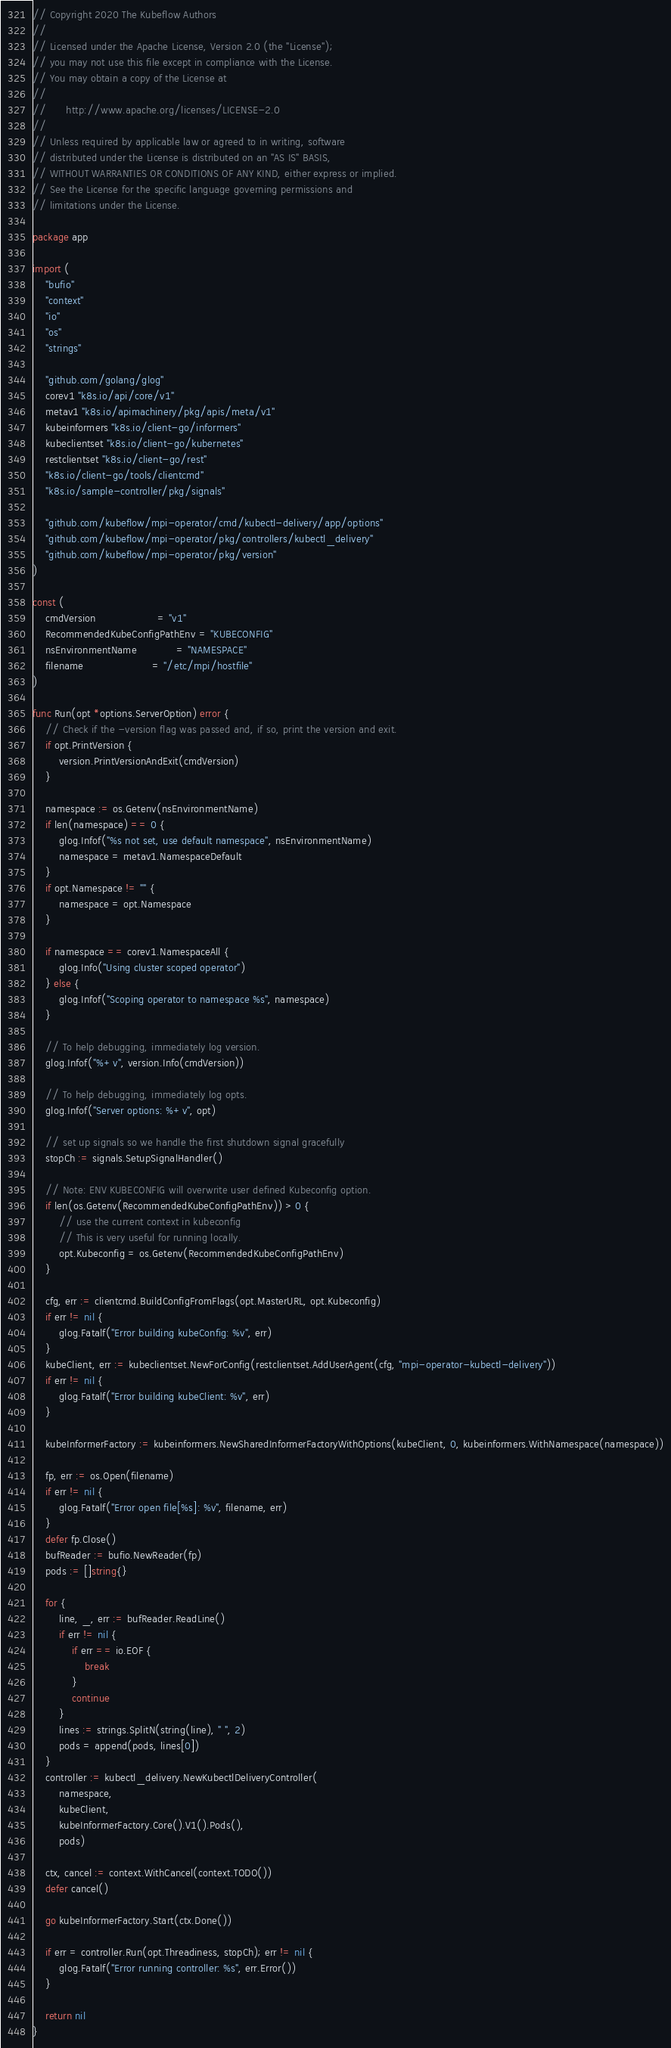<code> <loc_0><loc_0><loc_500><loc_500><_Go_>// Copyright 2020 The Kubeflow Authors
//
// Licensed under the Apache License, Version 2.0 (the "License");
// you may not use this file except in compliance with the License.
// You may obtain a copy of the License at
//
//      http://www.apache.org/licenses/LICENSE-2.0
//
// Unless required by applicable law or agreed to in writing, software
// distributed under the License is distributed on an "AS IS" BASIS,
// WITHOUT WARRANTIES OR CONDITIONS OF ANY KIND, either express or implied.
// See the License for the specific language governing permissions and
// limitations under the License.

package app

import (
	"bufio"
	"context"
	"io"
	"os"
	"strings"

	"github.com/golang/glog"
	corev1 "k8s.io/api/core/v1"
	metav1 "k8s.io/apimachinery/pkg/apis/meta/v1"
	kubeinformers "k8s.io/client-go/informers"
	kubeclientset "k8s.io/client-go/kubernetes"
	restclientset "k8s.io/client-go/rest"
	"k8s.io/client-go/tools/clientcmd"
	"k8s.io/sample-controller/pkg/signals"

	"github.com/kubeflow/mpi-operator/cmd/kubectl-delivery/app/options"
	"github.com/kubeflow/mpi-operator/pkg/controllers/kubectl_delivery"
	"github.com/kubeflow/mpi-operator/pkg/version"
)

const (
	cmdVersion                   = "v1"
	RecommendedKubeConfigPathEnv = "KUBECONFIG"
	nsEnvironmentName            = "NAMESPACE"
	filename                     = "/etc/mpi/hostfile"
)

func Run(opt *options.ServerOption) error {
	// Check if the -version flag was passed and, if so, print the version and exit.
	if opt.PrintVersion {
		version.PrintVersionAndExit(cmdVersion)
	}

	namespace := os.Getenv(nsEnvironmentName)
	if len(namespace) == 0 {
		glog.Infof("%s not set, use default namespace", nsEnvironmentName)
		namespace = metav1.NamespaceDefault
	}
	if opt.Namespace != "" {
		namespace = opt.Namespace
	}

	if namespace == corev1.NamespaceAll {
		glog.Info("Using cluster scoped operator")
	} else {
		glog.Infof("Scoping operator to namespace %s", namespace)
	}

	// To help debugging, immediately log version.
	glog.Infof("%+v", version.Info(cmdVersion))

	// To help debugging, immediately log opts.
	glog.Infof("Server options: %+v", opt)

	// set up signals so we handle the first shutdown signal gracefully
	stopCh := signals.SetupSignalHandler()

	// Note: ENV KUBECONFIG will overwrite user defined Kubeconfig option.
	if len(os.Getenv(RecommendedKubeConfigPathEnv)) > 0 {
		// use the current context in kubeconfig
		// This is very useful for running locally.
		opt.Kubeconfig = os.Getenv(RecommendedKubeConfigPathEnv)
	}

	cfg, err := clientcmd.BuildConfigFromFlags(opt.MasterURL, opt.Kubeconfig)
	if err != nil {
		glog.Fatalf("Error building kubeConfig: %v", err)
	}
	kubeClient, err := kubeclientset.NewForConfig(restclientset.AddUserAgent(cfg, "mpi-operator-kubectl-delivery"))
	if err != nil {
		glog.Fatalf("Error building kubeClient: %v", err)
	}

	kubeInformerFactory := kubeinformers.NewSharedInformerFactoryWithOptions(kubeClient, 0, kubeinformers.WithNamespace(namespace))

	fp, err := os.Open(filename)
	if err != nil {
		glog.Fatalf("Error open file[%s]: %v", filename, err)
	}
	defer fp.Close()
	bufReader := bufio.NewReader(fp)
	pods := []string{}

	for {
		line, _, err := bufReader.ReadLine()
		if err != nil {
			if err == io.EOF {
				break
			}
			continue
		}
		lines := strings.SplitN(string(line), " ", 2)
		pods = append(pods, lines[0])
	}
	controller := kubectl_delivery.NewKubectlDeliveryController(
		namespace,
		kubeClient,
		kubeInformerFactory.Core().V1().Pods(),
		pods)

	ctx, cancel := context.WithCancel(context.TODO())
	defer cancel()

	go kubeInformerFactory.Start(ctx.Done())

	if err = controller.Run(opt.Threadiness, stopCh); err != nil {
		glog.Fatalf("Error running controller: %s", err.Error())
	}

	return nil
}
</code> 